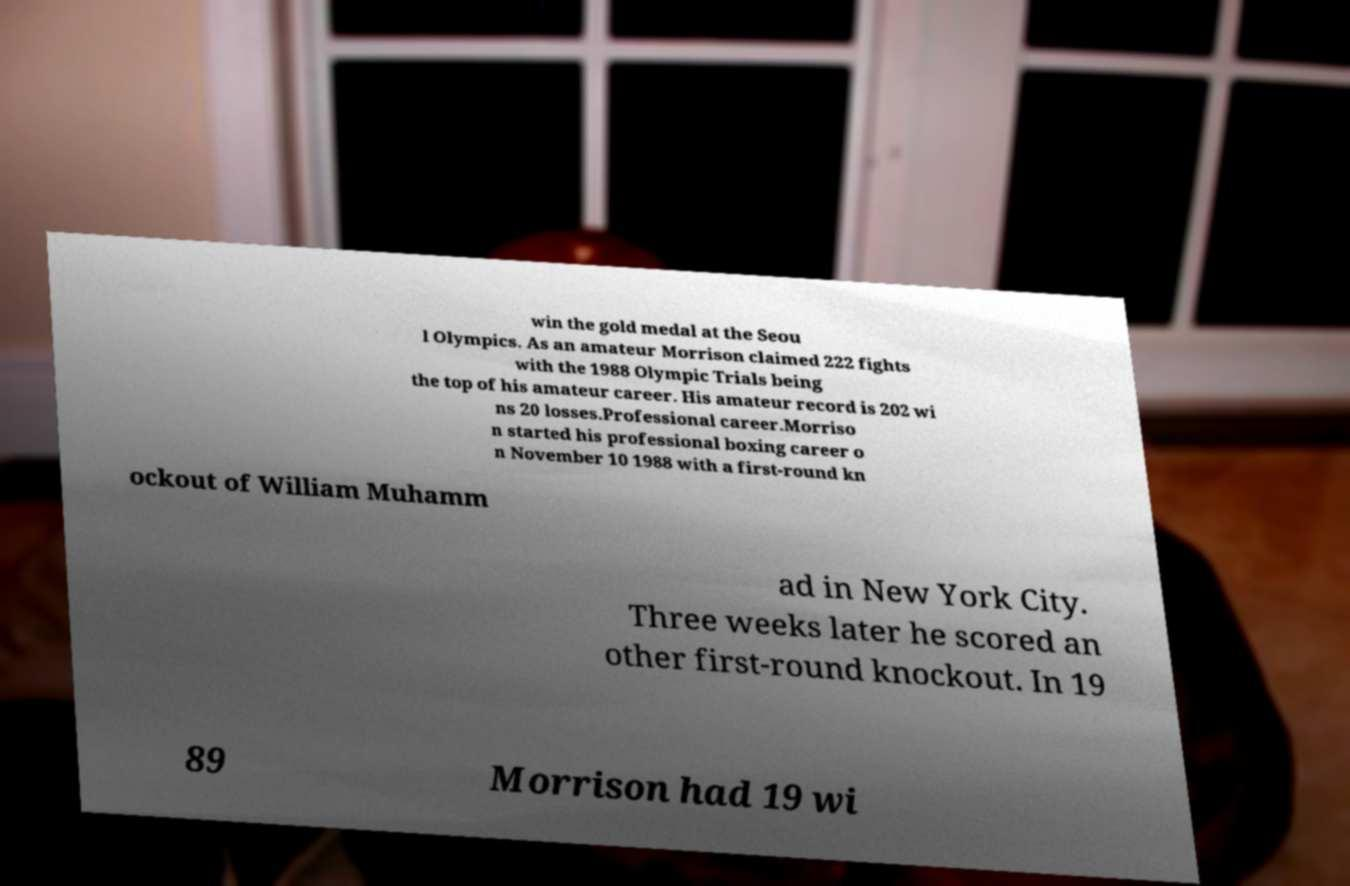Please read and relay the text visible in this image. What does it say? win the gold medal at the Seou l Olympics. As an amateur Morrison claimed 222 fights with the 1988 Olympic Trials being the top of his amateur career. His amateur record is 202 wi ns 20 losses.Professional career.Morriso n started his professional boxing career o n November 10 1988 with a first-round kn ockout of William Muhamm ad in New York City. Three weeks later he scored an other first-round knockout. In 19 89 Morrison had 19 wi 